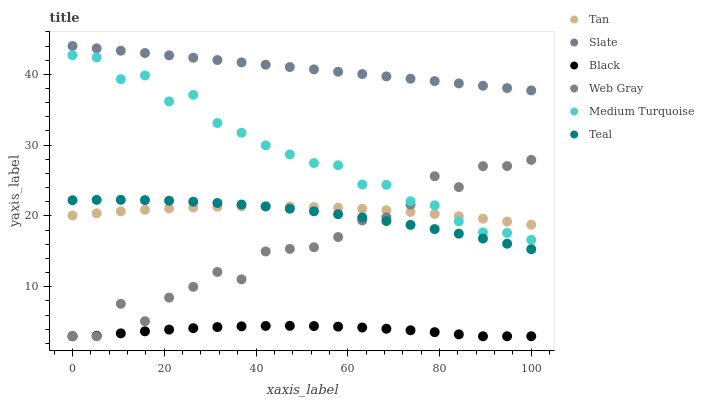Does Black have the minimum area under the curve?
Answer yes or no. Yes. Does Slate have the maximum area under the curve?
Answer yes or no. Yes. Does Medium Turquoise have the minimum area under the curve?
Answer yes or no. No. Does Medium Turquoise have the maximum area under the curve?
Answer yes or no. No. Is Slate the smoothest?
Answer yes or no. Yes. Is Web Gray the roughest?
Answer yes or no. Yes. Is Medium Turquoise the smoothest?
Answer yes or no. No. Is Medium Turquoise the roughest?
Answer yes or no. No. Does Web Gray have the lowest value?
Answer yes or no. Yes. Does Medium Turquoise have the lowest value?
Answer yes or no. No. Does Slate have the highest value?
Answer yes or no. Yes. Does Medium Turquoise have the highest value?
Answer yes or no. No. Is Black less than Medium Turquoise?
Answer yes or no. Yes. Is Slate greater than Tan?
Answer yes or no. Yes. Does Tan intersect Web Gray?
Answer yes or no. Yes. Is Tan less than Web Gray?
Answer yes or no. No. Is Tan greater than Web Gray?
Answer yes or no. No. Does Black intersect Medium Turquoise?
Answer yes or no. No. 